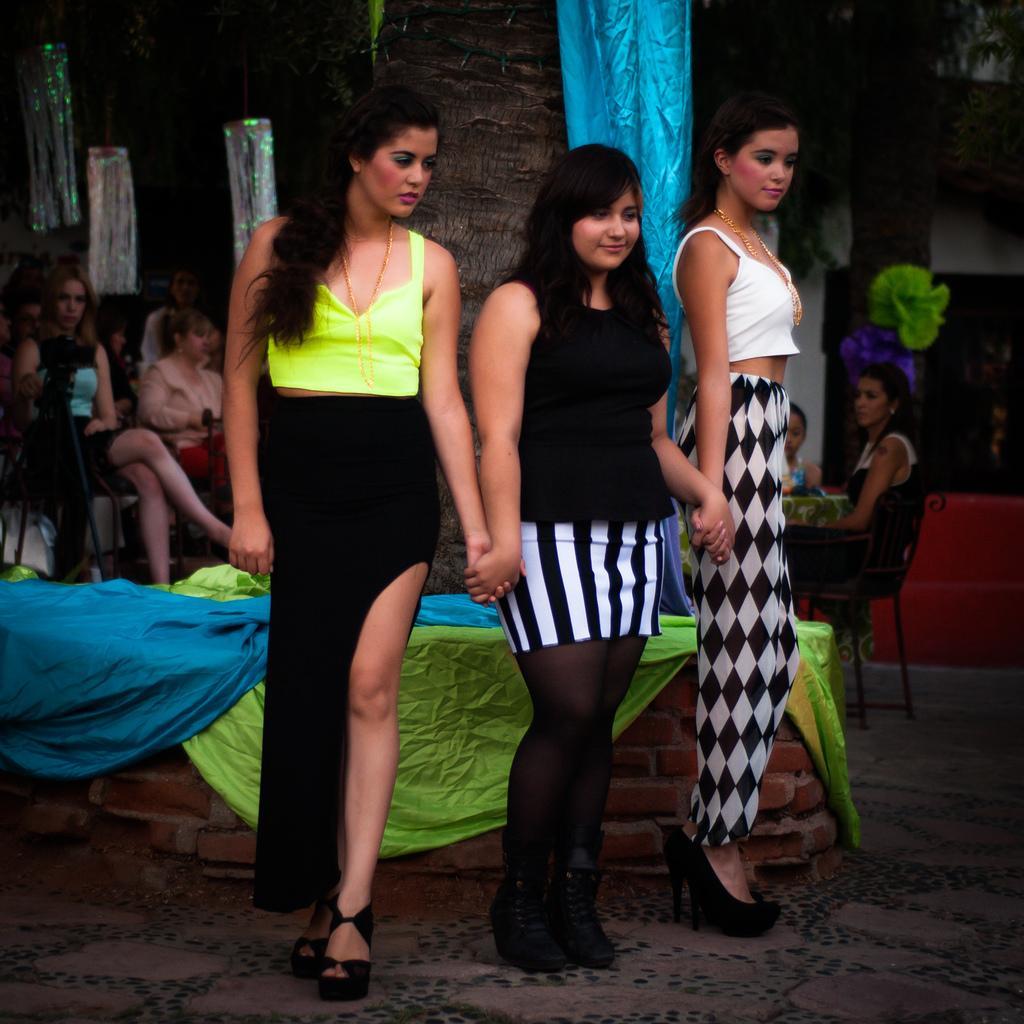Could you give a brief overview of what you see in this image? In the middle of the image three women are standing and smiling. Behind them there is a tree. Behind the tree few people are sitting and watching. 